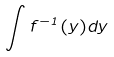Convert formula to latex. <formula><loc_0><loc_0><loc_500><loc_500>\int f ^ { - 1 } ( y ) d y</formula> 